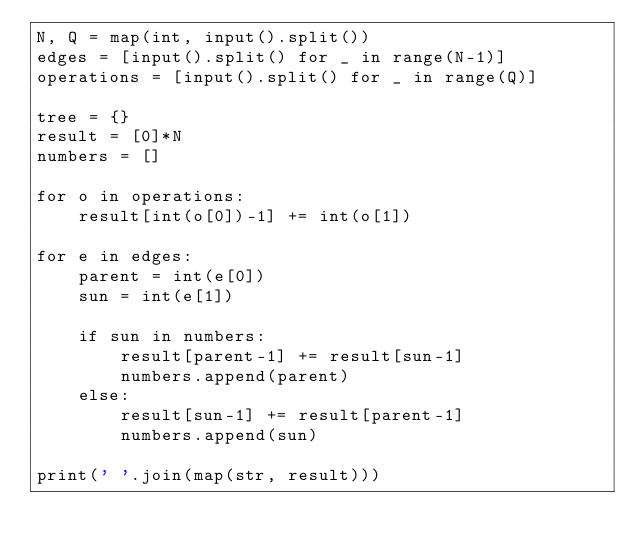<code> <loc_0><loc_0><loc_500><loc_500><_Python_>N, Q = map(int, input().split())
edges = [input().split() for _ in range(N-1)]
operations = [input().split() for _ in range(Q)]

tree = {}
result = [0]*N
numbers = []

for o in operations:
    result[int(o[0])-1] += int(o[1])

for e in edges:
    parent = int(e[0])
    sun = int(e[1])

    if sun in numbers:
        result[parent-1] += result[sun-1]
        numbers.append(parent)
    else:
        result[sun-1] += result[parent-1]
        numbers.append(sun)
        
print(' '.join(map(str, result)))</code> 